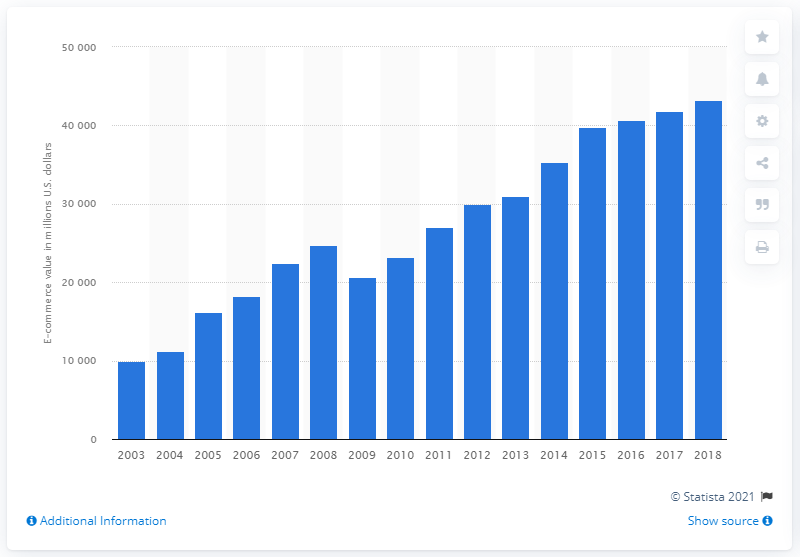Give some essential details in this illustration. The value of B2B e-commerce shipments for furniture and related products manufactured in the previous measured period was $41,785. In 2018, the value of B2B e-commerce shipments for furniture and related products manufacturing in the United States was $43,197. 